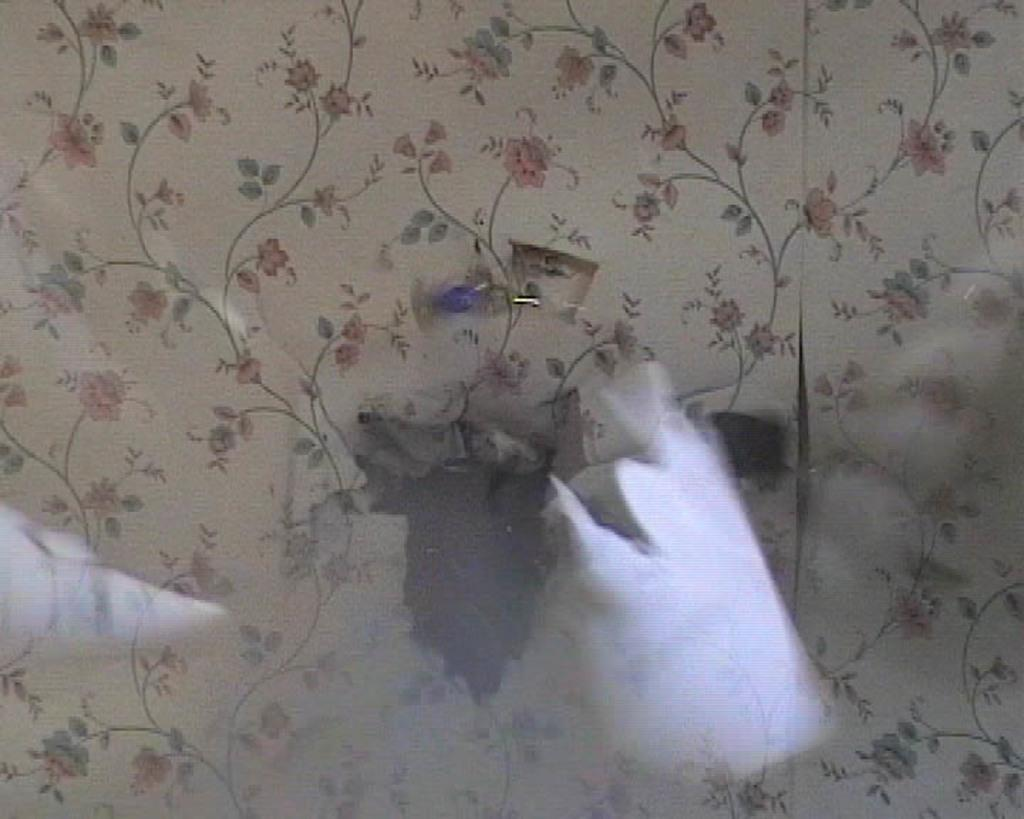What type of design can be seen on an object in the image? There is a flower design on an object in the image. How many women are depicted in the flower design in the image? There are no women depicted in the flower design in the image, as it is a design featuring flowers. 